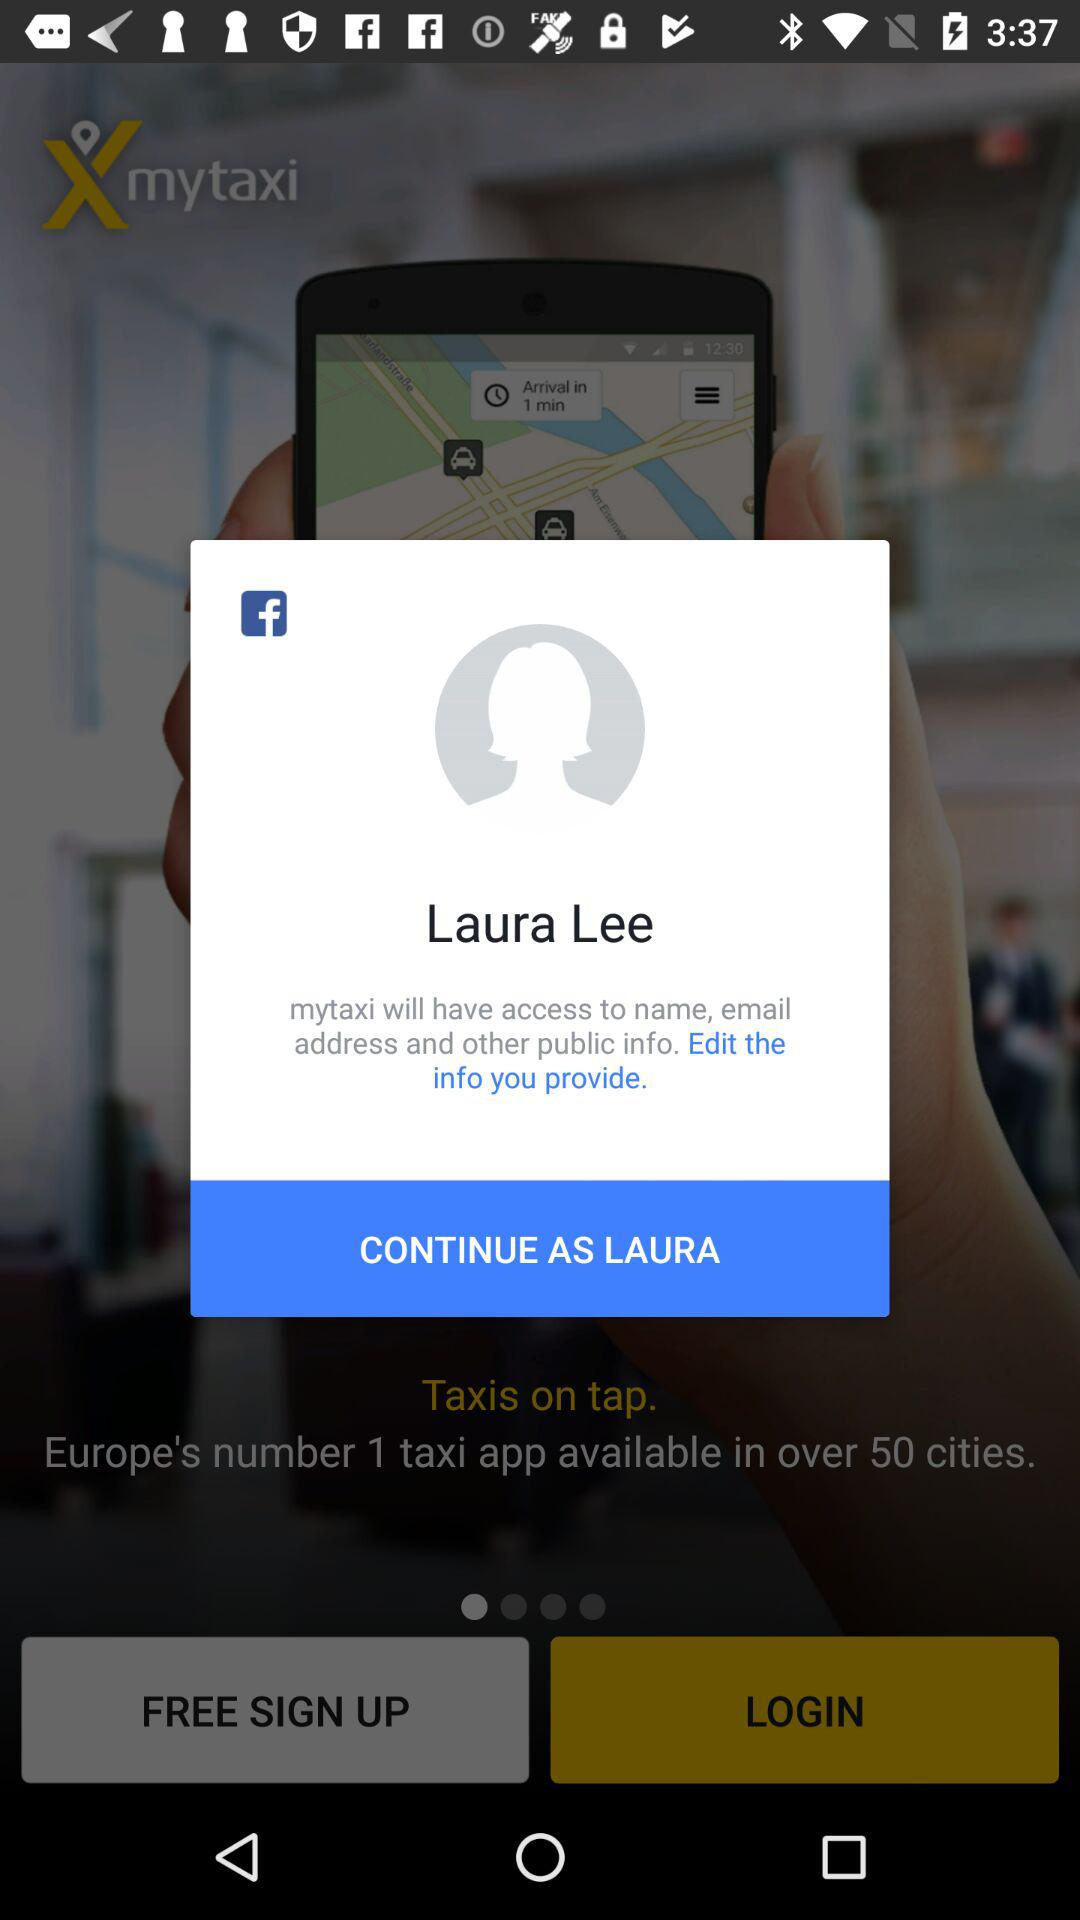What is the name of the user? The name of the user is Laura Lee. 